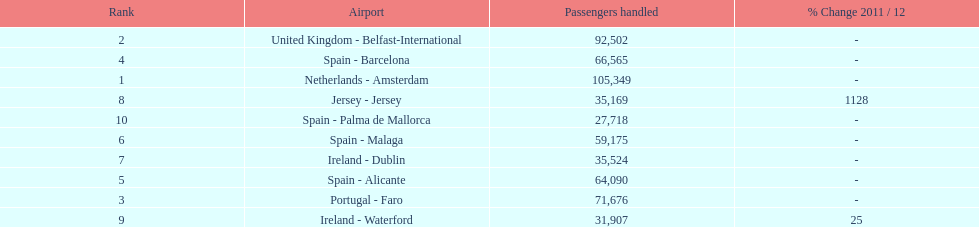I'm looking to parse the entire table for insights. Could you assist me with that? {'header': ['Rank', 'Airport', 'Passengers handled', '% Change 2011 / 12'], 'rows': [['2', 'United Kingdom - Belfast-International', '92,502', '-'], ['4', 'Spain - Barcelona', '66,565', '-'], ['1', 'Netherlands - Amsterdam', '105,349', '-'], ['8', 'Jersey - Jersey', '35,169', '1128'], ['10', 'Spain - Palma de Mallorca', '27,718', '-'], ['6', 'Spain - Malaga', '59,175', '-'], ['7', 'Ireland - Dublin', '35,524', '-'], ['5', 'Spain - Alicante', '64,090', '-'], ['3', 'Portugal - Faro', '71,676', '-'], ['9', 'Ireland - Waterford', '31,907', '25']]} Between the topped ranked airport, netherlands - amsterdam, & spain - palma de mallorca, what is the difference in the amount of passengers handled? 77,631. 